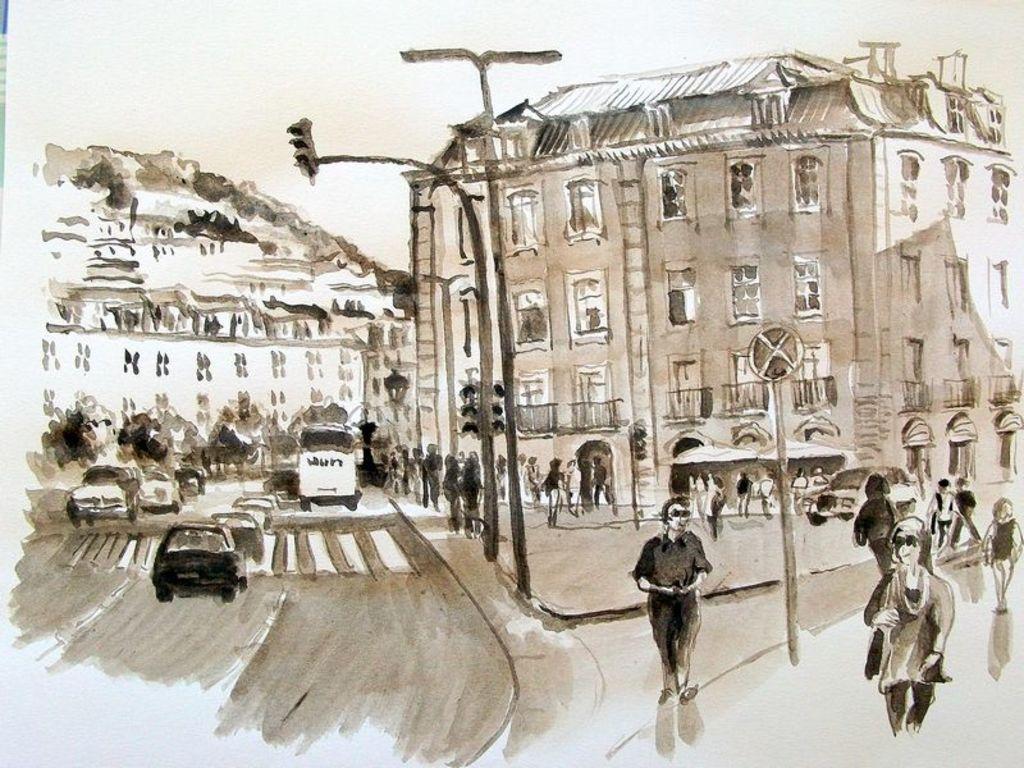Can you describe this image briefly? In the foreground of this painted image, on the bottom, there is a road, few vehicles moving on the road and persons walking. We can also see poles, sign board, buildings and the sky. 